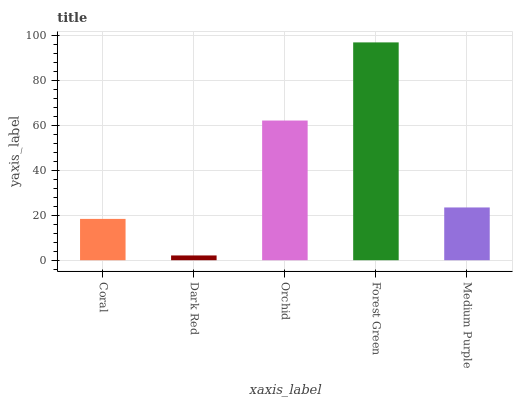Is Dark Red the minimum?
Answer yes or no. Yes. Is Forest Green the maximum?
Answer yes or no. Yes. Is Orchid the minimum?
Answer yes or no. No. Is Orchid the maximum?
Answer yes or no. No. Is Orchid greater than Dark Red?
Answer yes or no. Yes. Is Dark Red less than Orchid?
Answer yes or no. Yes. Is Dark Red greater than Orchid?
Answer yes or no. No. Is Orchid less than Dark Red?
Answer yes or no. No. Is Medium Purple the high median?
Answer yes or no. Yes. Is Medium Purple the low median?
Answer yes or no. Yes. Is Coral the high median?
Answer yes or no. No. Is Coral the low median?
Answer yes or no. No. 